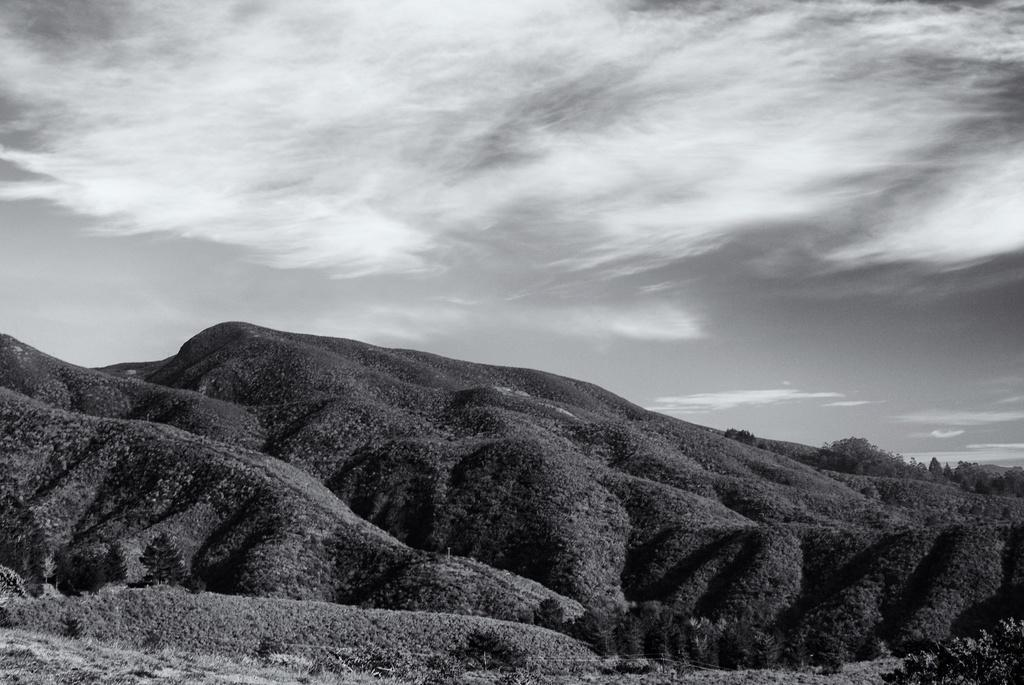What is the color scheme of the image? The image is black and white. What type of surface can be seen in the image? There is a surface with a lot of grass in the image. How many bikes are present on the page in the image? There is no page or bikes present in the image; it is a black and white image featuring a surface with a lot of grass. 